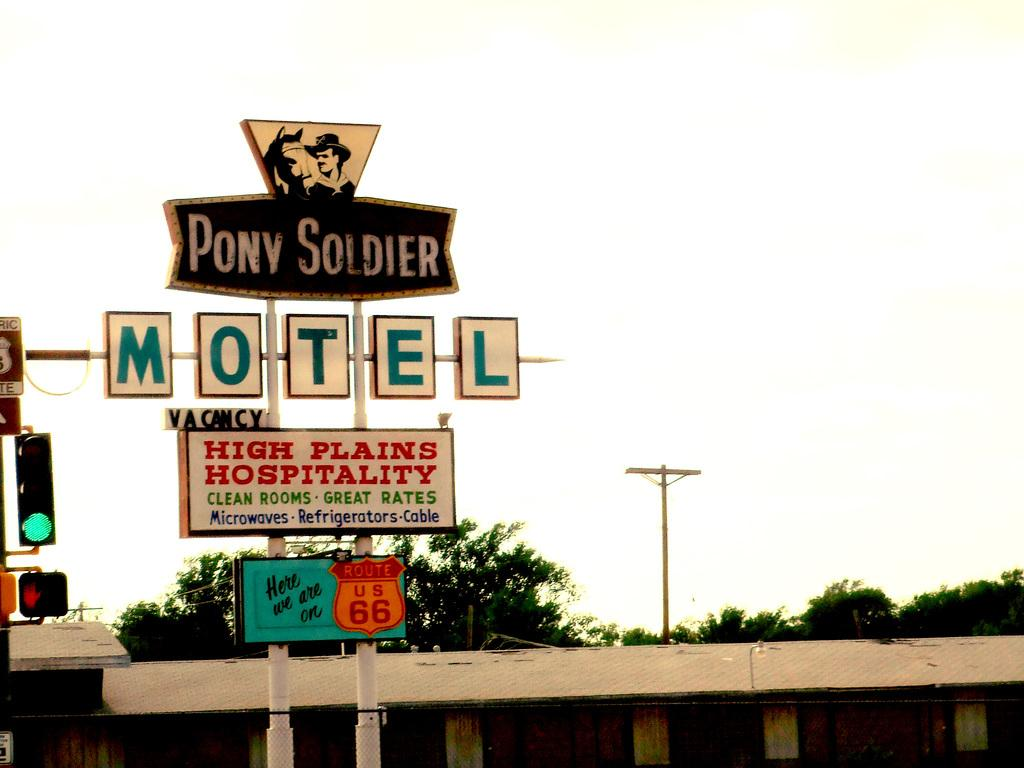What objects can be seen in the image that are related to infrastructure? In the image, there are boards, poles, and traffic signals related to infrastructure. What type of structure is present in the image? There is a shed in the image. What type of vegetation is visible in the image? Trees are visible in the image. What can be seen in the background of the image? The sky is visible in the background of the image. What type of sofa can be seen in the image? There is no sofa present in the image. What emotion is the powder feeling in the image? There is no powder or emotion associated with it in the image. 